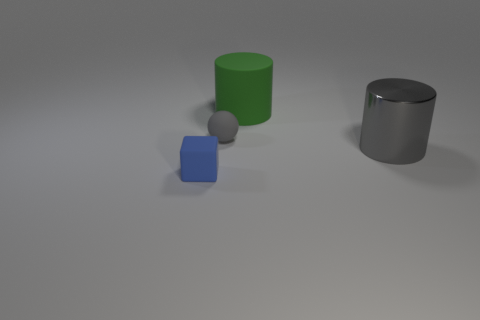Subtract all green cylinders. How many cylinders are left? 1 Subtract all cubes. How many objects are left? 3 Add 1 matte cubes. How many objects exist? 5 Subtract 1 gray spheres. How many objects are left? 3 Subtract 1 cubes. How many cubes are left? 0 Subtract all cyan cylinders. Subtract all gray spheres. How many cylinders are left? 2 Subtract all tiny matte cylinders. Subtract all big shiny things. How many objects are left? 3 Add 1 small gray balls. How many small gray balls are left? 2 Add 1 green metal cubes. How many green metal cubes exist? 1 